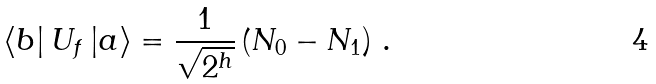<formula> <loc_0><loc_0><loc_500><loc_500>\left \langle b \right | U _ { f } \left | a \right \rangle = \frac { 1 } { { \sqrt { 2 ^ { h } } } } \left ( { N _ { 0 } - N _ { 1 } } \right ) \, .</formula> 